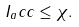<formula> <loc_0><loc_0><loc_500><loc_500>I _ { a } c c \leq \chi .</formula> 